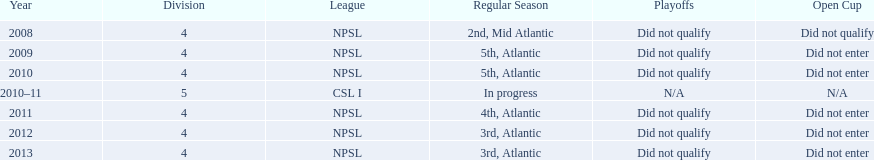How many years did they not qualify for the playoffs? 6. 